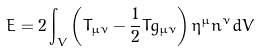<formula> <loc_0><loc_0><loc_500><loc_500>E = 2 \int _ { V } \left ( T _ { \mu \nu } - \frac { 1 } { 2 } T g _ { \mu \nu } \right ) \eta ^ { \mu } n ^ { \nu } d V</formula> 